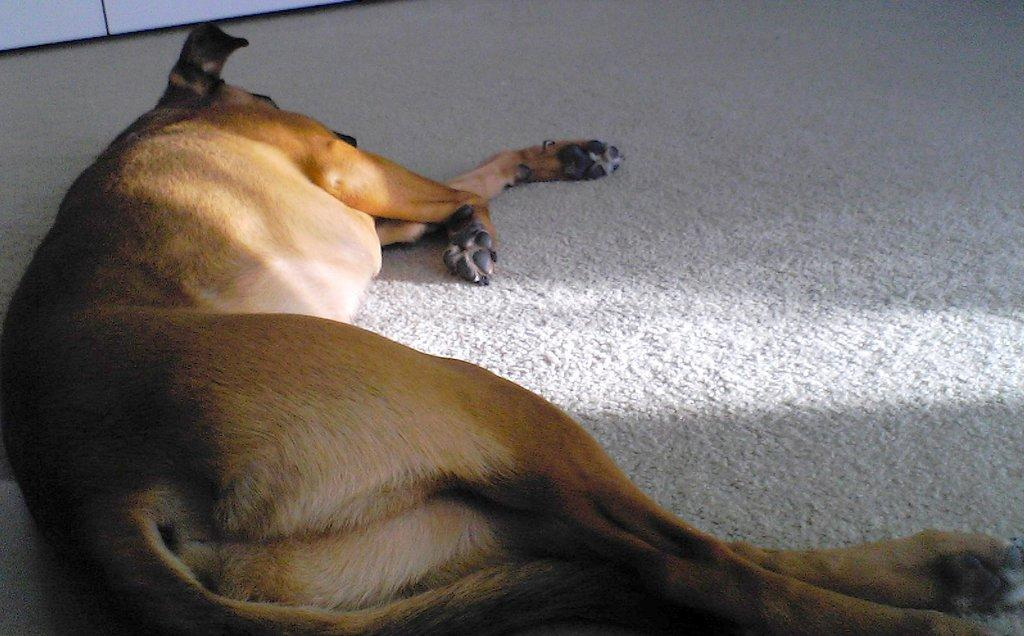What type of animal can be seen in the image? There is an animal in the image. What is the animal doing in the image? The animal is sleeping on the floor. Can you describe the object at the top of the image? Unfortunately, the facts provided do not give any information about the object at the top of the image. What force is causing the animal to grow in the image? There is no indication of growth or any force causing growth in the image. The animal is simply sleeping on the floor. Is there a faucet visible in the image? There is no mention of a faucet in the provided facts, so we cannot determine if one is present in the image. 